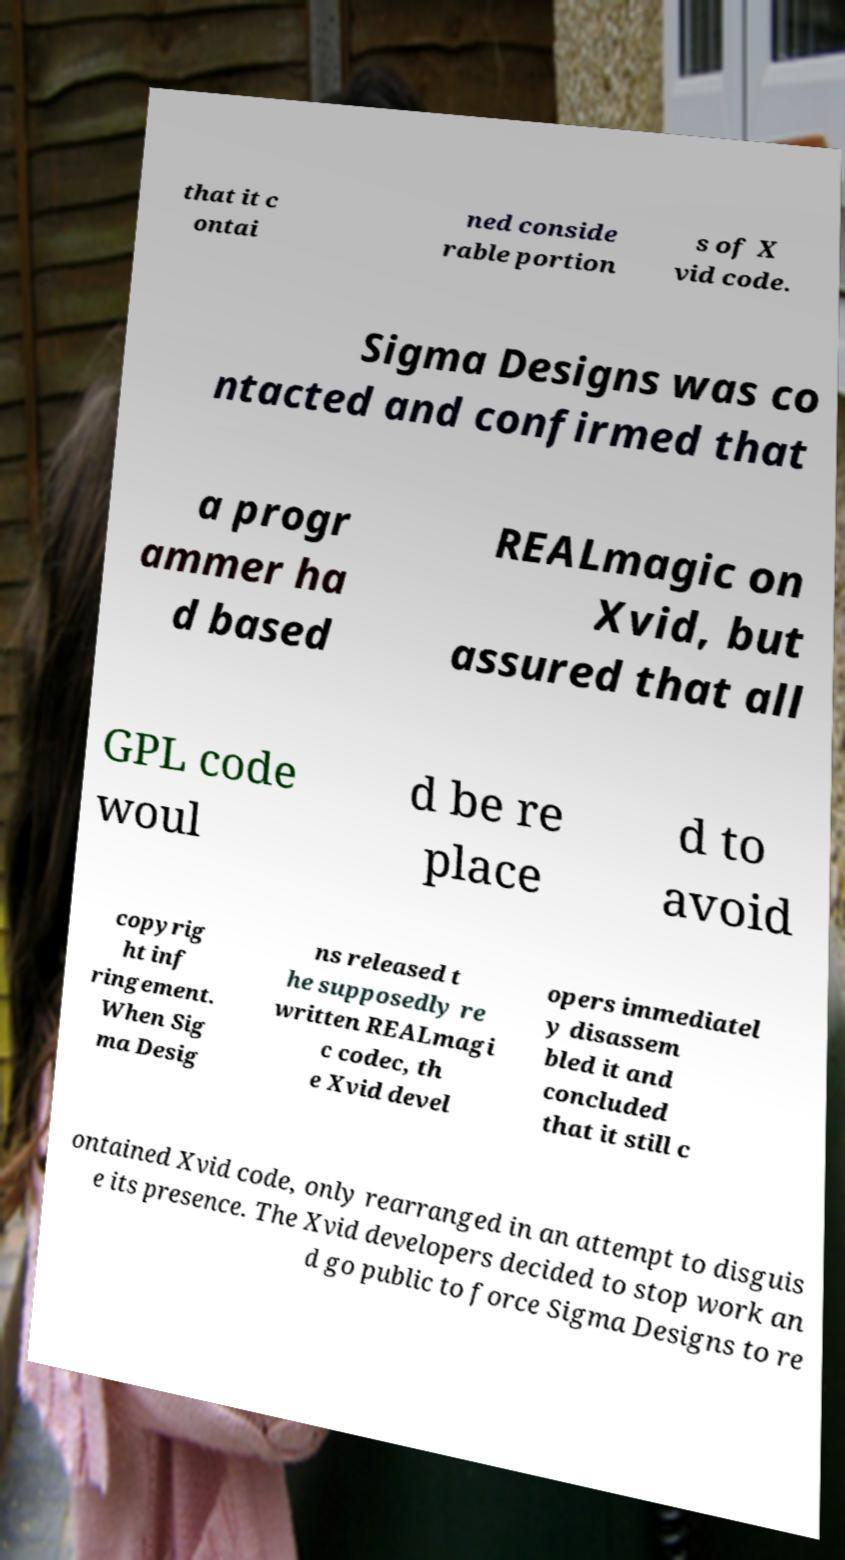Can you read and provide the text displayed in the image?This photo seems to have some interesting text. Can you extract and type it out for me? that it c ontai ned conside rable portion s of X vid code. Sigma Designs was co ntacted and confirmed that a progr ammer ha d based REALmagic on Xvid, but assured that all GPL code woul d be re place d to avoid copyrig ht inf ringement. When Sig ma Desig ns released t he supposedly re written REALmagi c codec, th e Xvid devel opers immediatel y disassem bled it and concluded that it still c ontained Xvid code, only rearranged in an attempt to disguis e its presence. The Xvid developers decided to stop work an d go public to force Sigma Designs to re 